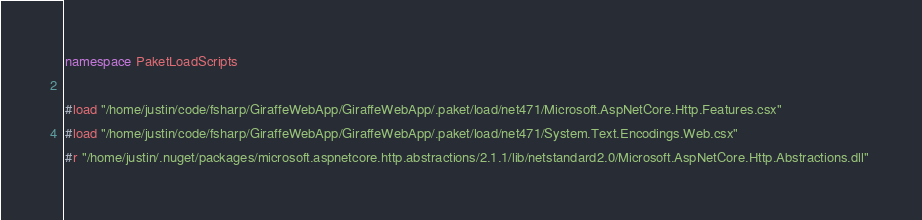Convert code to text. <code><loc_0><loc_0><loc_500><loc_500><_C#_>namespace PaketLoadScripts

#load "/home/justin/code/fsharp/GiraffeWebApp/GiraffeWebApp/.paket/load/net471/Microsoft.AspNetCore.Http.Features.csx" 
#load "/home/justin/code/fsharp/GiraffeWebApp/GiraffeWebApp/.paket/load/net471/System.Text.Encodings.Web.csx" 
#r "/home/justin/.nuget/packages/microsoft.aspnetcore.http.abstractions/2.1.1/lib/netstandard2.0/Microsoft.AspNetCore.Http.Abstractions.dll" </code> 